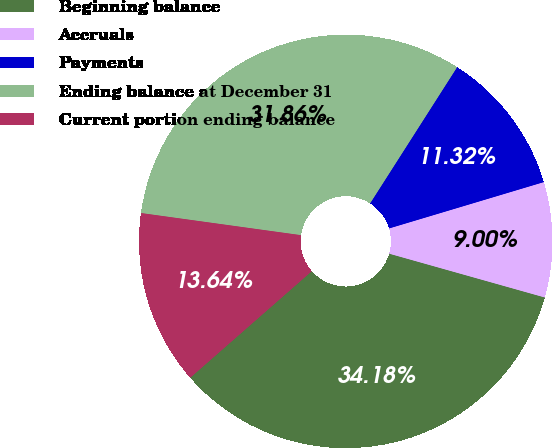Convert chart. <chart><loc_0><loc_0><loc_500><loc_500><pie_chart><fcel>Beginning balance<fcel>Accruals<fcel>Payments<fcel>Ending balance at December 31<fcel>Current portion ending balance<nl><fcel>34.18%<fcel>9.0%<fcel>11.32%<fcel>31.86%<fcel>13.64%<nl></chart> 